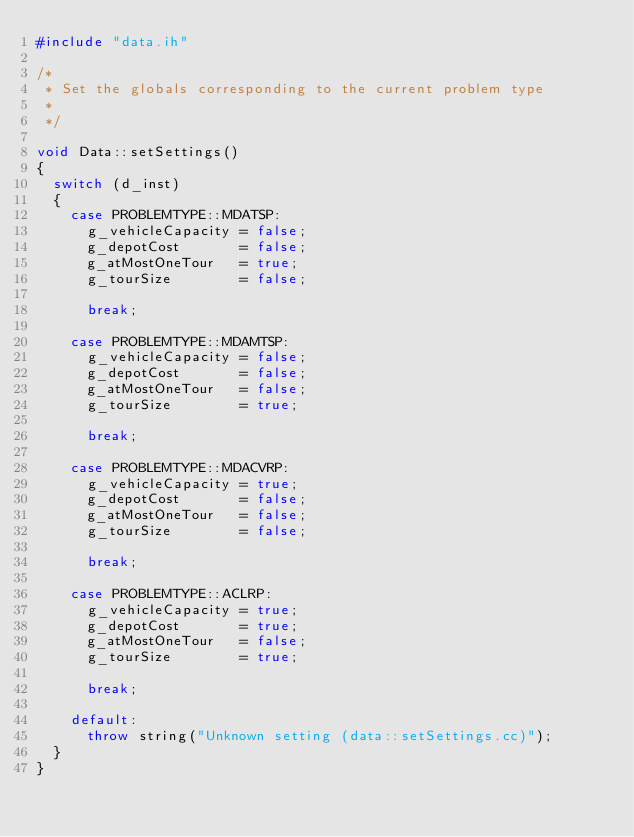<code> <loc_0><loc_0><loc_500><loc_500><_C++_>#include "data.ih"

/*
 * Set the globals corresponding to the current problem type
 * 
 */

void Data::setSettings()
{
  switch (d_inst)
  {
    case PROBLEMTYPE::MDATSP:
      g_vehicleCapacity = false;
      g_depotCost       = false;
      g_atMostOneTour   = true;
      g_tourSize        = false;
      
      break;
      
    case PROBLEMTYPE::MDAMTSP:
      g_vehicleCapacity = false;
      g_depotCost       = false;
      g_atMostOneTour   = false;
      g_tourSize        = true;  
      
      break;
      
    case PROBLEMTYPE::MDACVRP:
      g_vehicleCapacity = true;
      g_depotCost       = false;
      g_atMostOneTour   = false;
      g_tourSize        = false;
      
      break;
      
    case PROBLEMTYPE::ACLRP:
      g_vehicleCapacity = true;
      g_depotCost       = true;
      g_atMostOneTour   = false;
      g_tourSize        = true;
      
      break;
      
    default: 
      throw string("Unknown setting (data::setSettings.cc)");
  }
}
</code> 